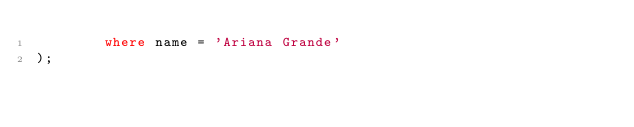Convert code to text. <code><loc_0><loc_0><loc_500><loc_500><_SQL_>        where name = 'Ariana Grande'
);</code> 